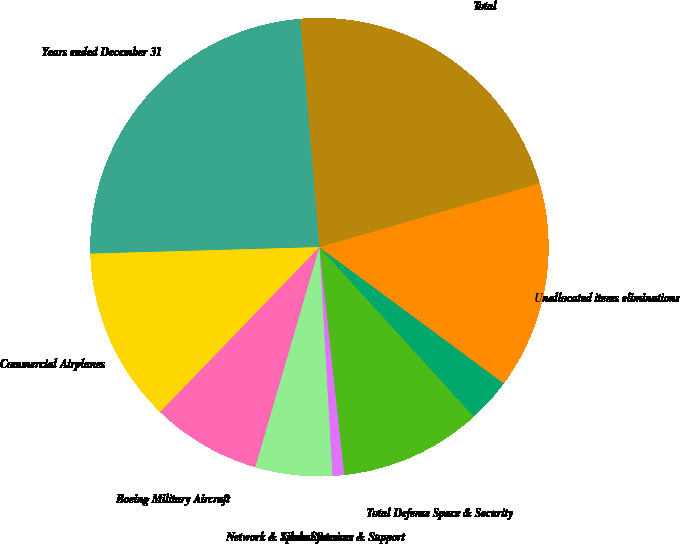<chart> <loc_0><loc_0><loc_500><loc_500><pie_chart><fcel>Years ended December 31<fcel>Commercial Airplanes<fcel>Boeing Military Aircraft<fcel>Network & Space Systems<fcel>Global Services & Support<fcel>Total Defense Space & Security<fcel>Boeing Capital Corporation<fcel>Unallocated items eliminations<fcel>Total<nl><fcel>24.13%<fcel>12.32%<fcel>7.72%<fcel>5.42%<fcel>0.82%<fcel>10.02%<fcel>3.12%<fcel>14.62%<fcel>21.83%<nl></chart> 